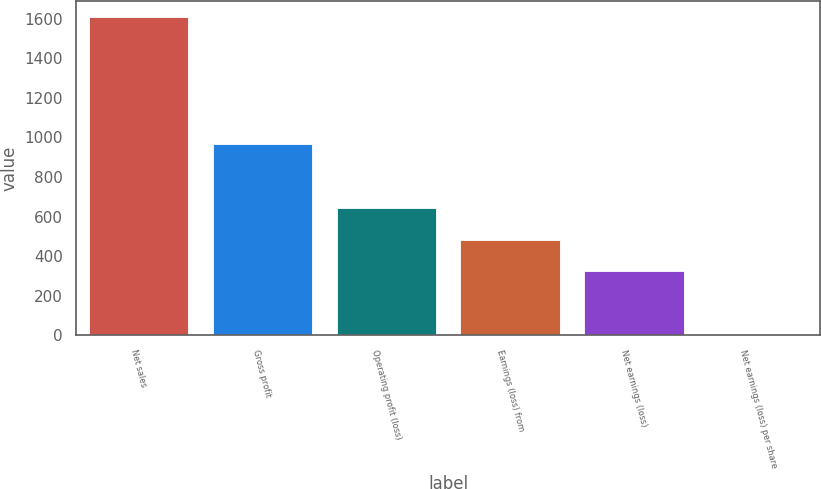Convert chart. <chart><loc_0><loc_0><loc_500><loc_500><bar_chart><fcel>Net sales<fcel>Gross profit<fcel>Operating profit (loss)<fcel>Earnings (loss) from<fcel>Net earnings (loss)<fcel>Net earnings (loss) per share<nl><fcel>1609<fcel>965.71<fcel>644.07<fcel>483.25<fcel>322.43<fcel>0.79<nl></chart> 